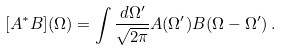Convert formula to latex. <formula><loc_0><loc_0><loc_500><loc_500>[ A ^ { * } B ] ( \Omega ) = \int \frac { d \Omega ^ { \prime } } { \sqrt { 2 \pi } } A ( \Omega ^ { \prime } ) B ( \Omega - \Omega ^ { \prime } ) \, .</formula> 